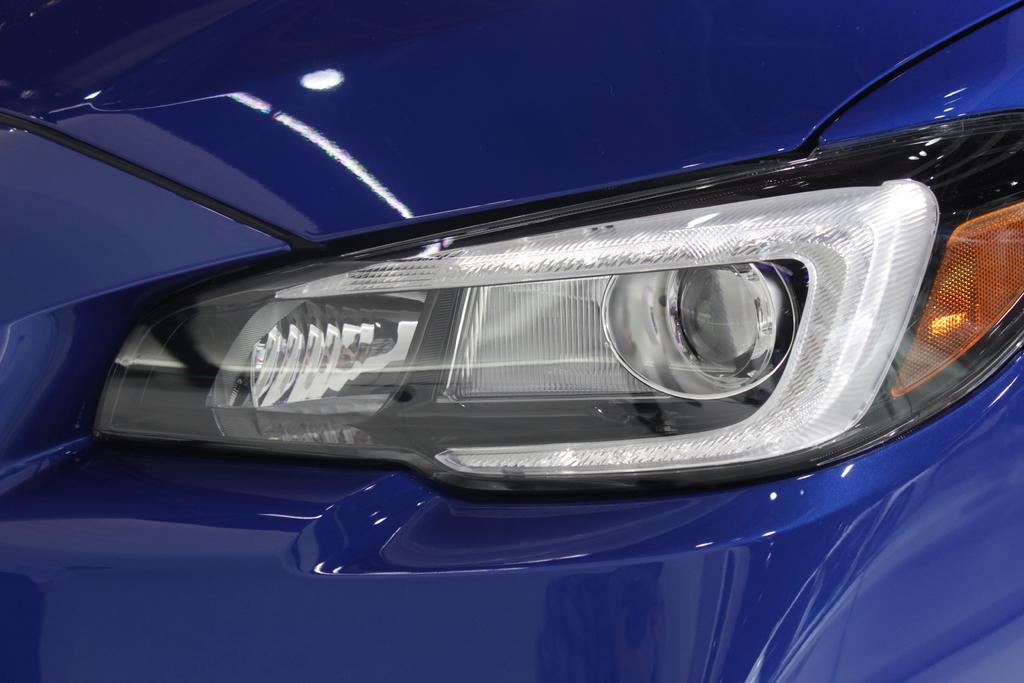What color is the car in the image? The car in the image is blue. What features can be seen on the car? The car has headlights. Is there any effect of light on the car in the image? Yes, there is a reflection of light on the car. How many lizards are sitting on the car in the image? There are no lizards present in the image; it only features a blue car with headlights and a reflection of light. 